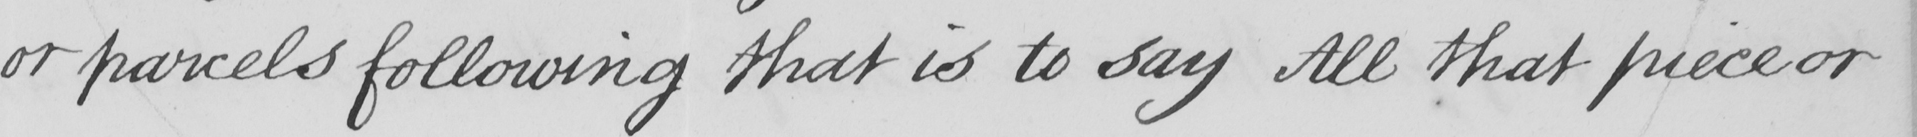Can you read and transcribe this handwriting? or parcels following that is to say All that piece or 